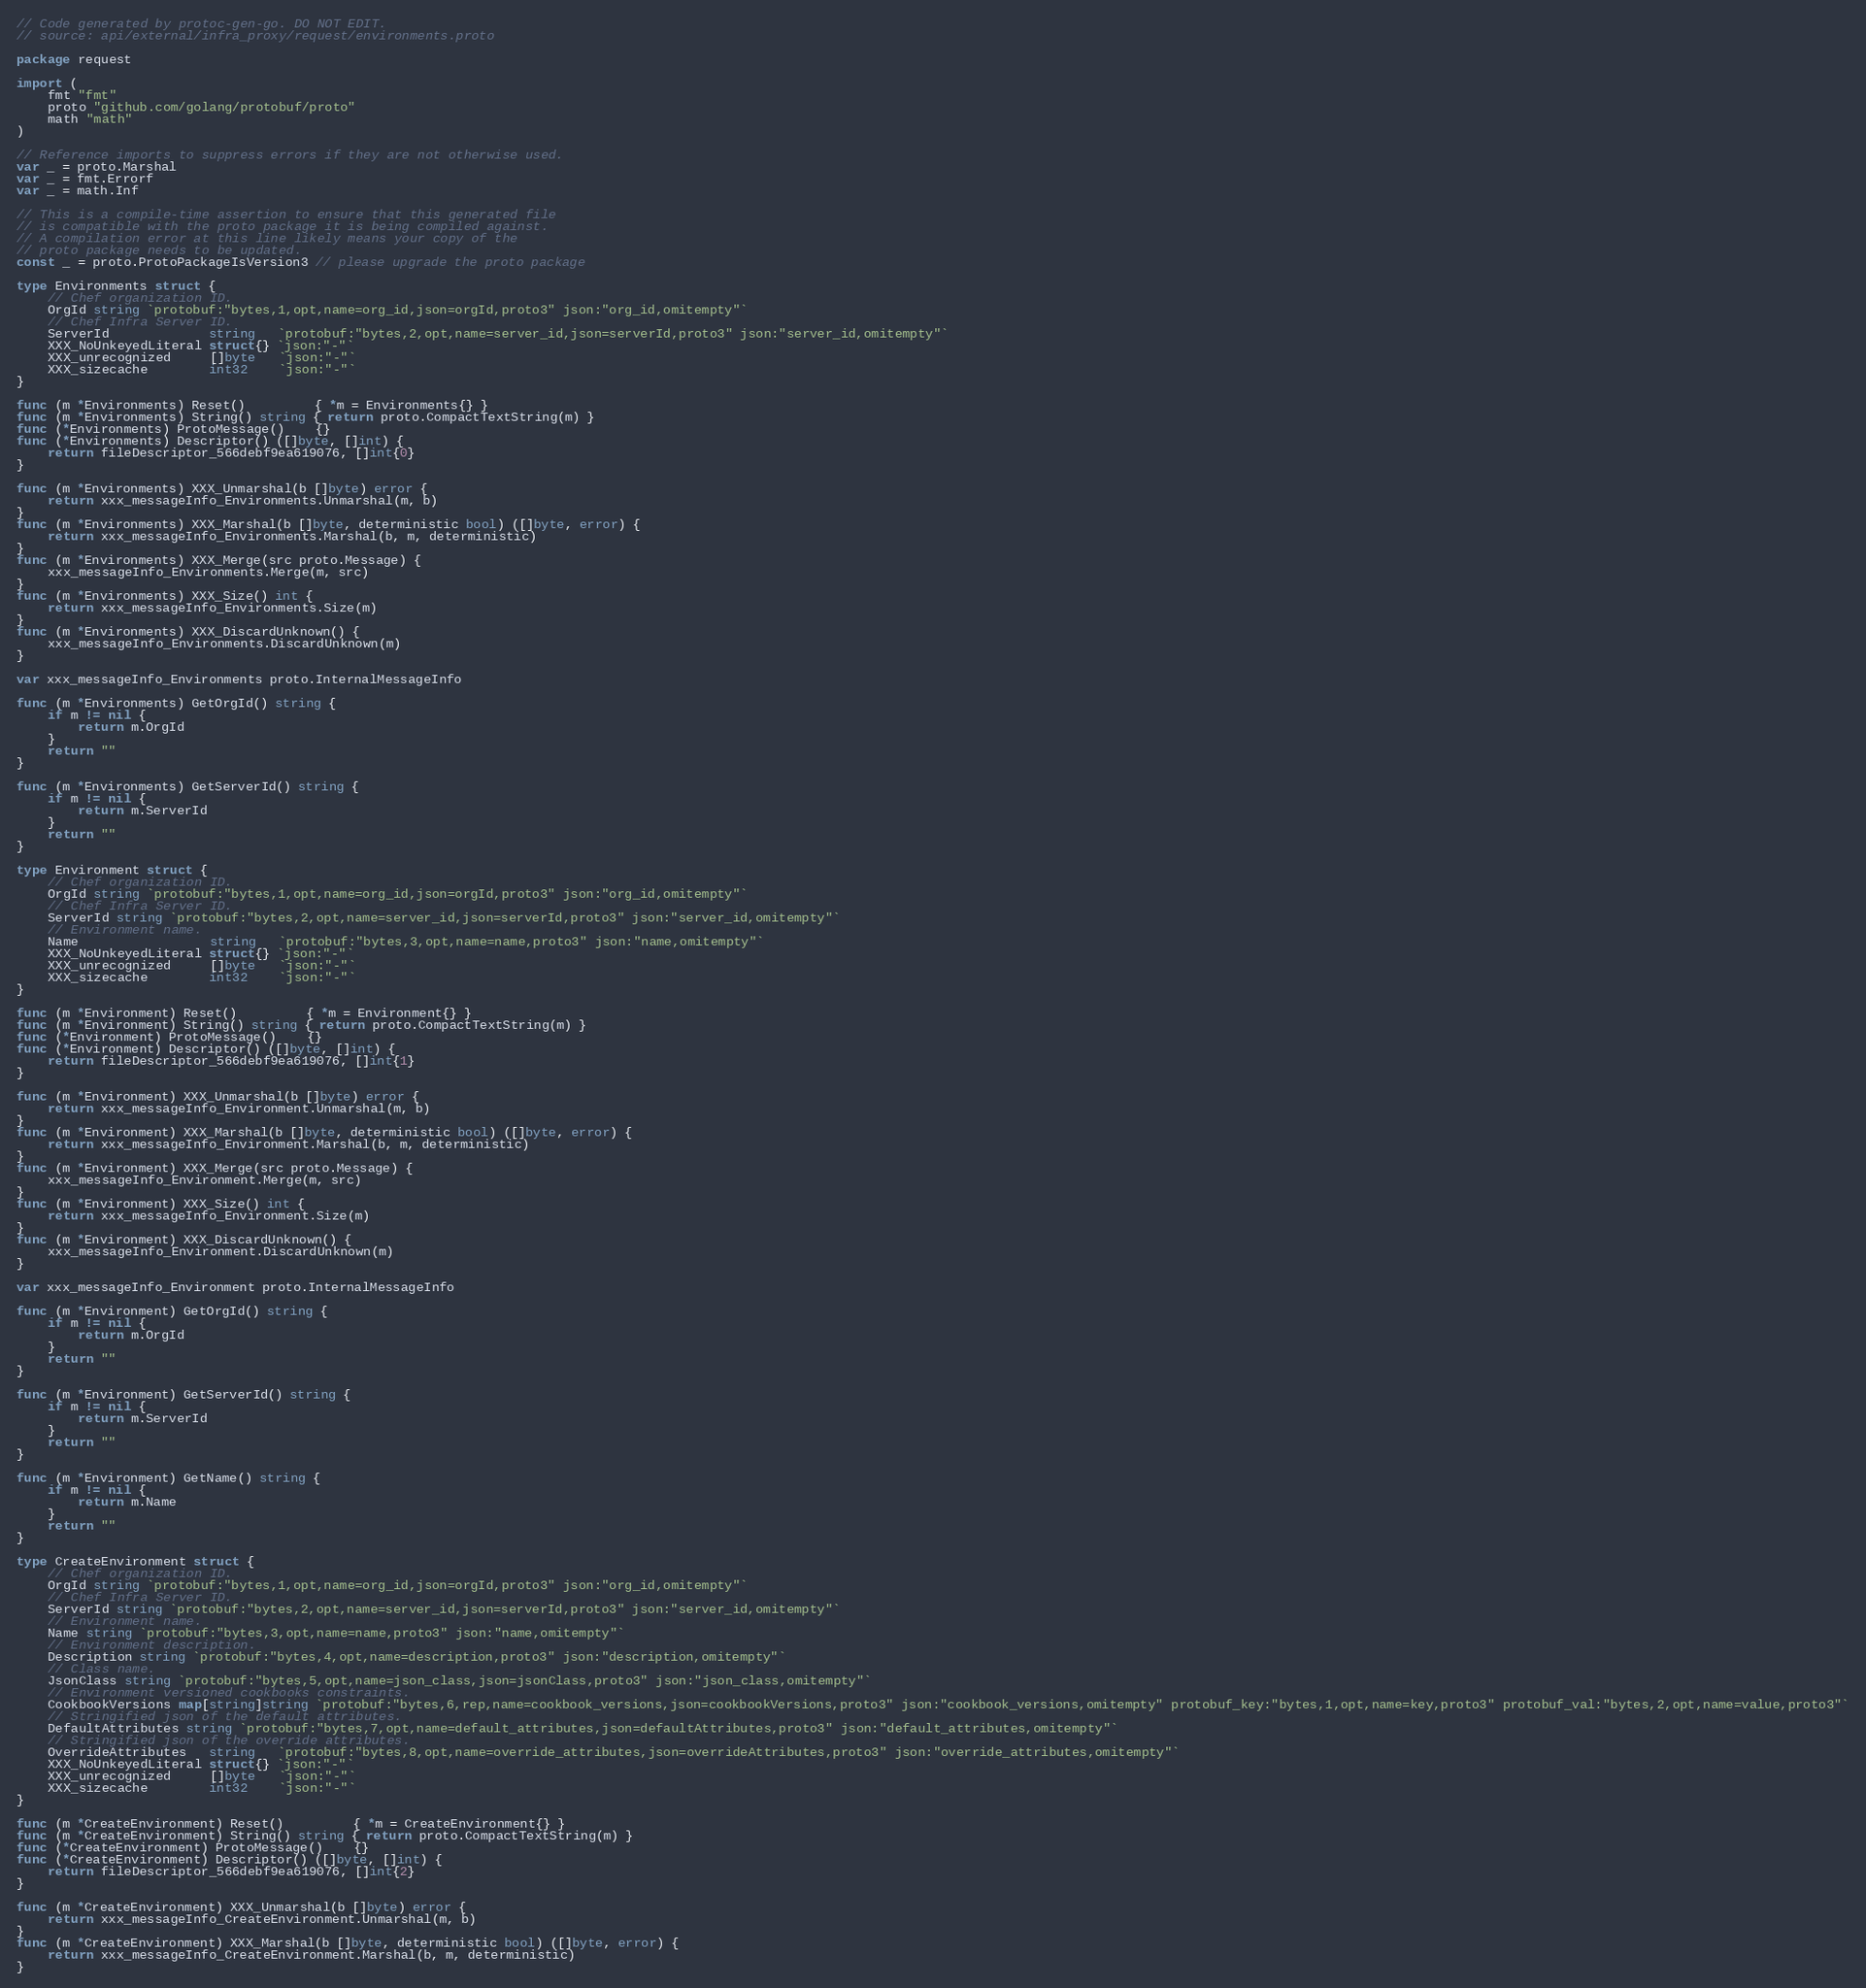<code> <loc_0><loc_0><loc_500><loc_500><_Go_>// Code generated by protoc-gen-go. DO NOT EDIT.
// source: api/external/infra_proxy/request/environments.proto

package request

import (
	fmt "fmt"
	proto "github.com/golang/protobuf/proto"
	math "math"
)

// Reference imports to suppress errors if they are not otherwise used.
var _ = proto.Marshal
var _ = fmt.Errorf
var _ = math.Inf

// This is a compile-time assertion to ensure that this generated file
// is compatible with the proto package it is being compiled against.
// A compilation error at this line likely means your copy of the
// proto package needs to be updated.
const _ = proto.ProtoPackageIsVersion3 // please upgrade the proto package

type Environments struct {
	// Chef organization ID.
	OrgId string `protobuf:"bytes,1,opt,name=org_id,json=orgId,proto3" json:"org_id,omitempty"`
	// Chef Infra Server ID.
	ServerId             string   `protobuf:"bytes,2,opt,name=server_id,json=serverId,proto3" json:"server_id,omitempty"`
	XXX_NoUnkeyedLiteral struct{} `json:"-"`
	XXX_unrecognized     []byte   `json:"-"`
	XXX_sizecache        int32    `json:"-"`
}

func (m *Environments) Reset()         { *m = Environments{} }
func (m *Environments) String() string { return proto.CompactTextString(m) }
func (*Environments) ProtoMessage()    {}
func (*Environments) Descriptor() ([]byte, []int) {
	return fileDescriptor_566debf9ea619076, []int{0}
}

func (m *Environments) XXX_Unmarshal(b []byte) error {
	return xxx_messageInfo_Environments.Unmarshal(m, b)
}
func (m *Environments) XXX_Marshal(b []byte, deterministic bool) ([]byte, error) {
	return xxx_messageInfo_Environments.Marshal(b, m, deterministic)
}
func (m *Environments) XXX_Merge(src proto.Message) {
	xxx_messageInfo_Environments.Merge(m, src)
}
func (m *Environments) XXX_Size() int {
	return xxx_messageInfo_Environments.Size(m)
}
func (m *Environments) XXX_DiscardUnknown() {
	xxx_messageInfo_Environments.DiscardUnknown(m)
}

var xxx_messageInfo_Environments proto.InternalMessageInfo

func (m *Environments) GetOrgId() string {
	if m != nil {
		return m.OrgId
	}
	return ""
}

func (m *Environments) GetServerId() string {
	if m != nil {
		return m.ServerId
	}
	return ""
}

type Environment struct {
	// Chef organization ID.
	OrgId string `protobuf:"bytes,1,opt,name=org_id,json=orgId,proto3" json:"org_id,omitempty"`
	// Chef Infra Server ID.
	ServerId string `protobuf:"bytes,2,opt,name=server_id,json=serverId,proto3" json:"server_id,omitempty"`
	// Environment name.
	Name                 string   `protobuf:"bytes,3,opt,name=name,proto3" json:"name,omitempty"`
	XXX_NoUnkeyedLiteral struct{} `json:"-"`
	XXX_unrecognized     []byte   `json:"-"`
	XXX_sizecache        int32    `json:"-"`
}

func (m *Environment) Reset()         { *m = Environment{} }
func (m *Environment) String() string { return proto.CompactTextString(m) }
func (*Environment) ProtoMessage()    {}
func (*Environment) Descriptor() ([]byte, []int) {
	return fileDescriptor_566debf9ea619076, []int{1}
}

func (m *Environment) XXX_Unmarshal(b []byte) error {
	return xxx_messageInfo_Environment.Unmarshal(m, b)
}
func (m *Environment) XXX_Marshal(b []byte, deterministic bool) ([]byte, error) {
	return xxx_messageInfo_Environment.Marshal(b, m, deterministic)
}
func (m *Environment) XXX_Merge(src proto.Message) {
	xxx_messageInfo_Environment.Merge(m, src)
}
func (m *Environment) XXX_Size() int {
	return xxx_messageInfo_Environment.Size(m)
}
func (m *Environment) XXX_DiscardUnknown() {
	xxx_messageInfo_Environment.DiscardUnknown(m)
}

var xxx_messageInfo_Environment proto.InternalMessageInfo

func (m *Environment) GetOrgId() string {
	if m != nil {
		return m.OrgId
	}
	return ""
}

func (m *Environment) GetServerId() string {
	if m != nil {
		return m.ServerId
	}
	return ""
}

func (m *Environment) GetName() string {
	if m != nil {
		return m.Name
	}
	return ""
}

type CreateEnvironment struct {
	// Chef organization ID.
	OrgId string `protobuf:"bytes,1,opt,name=org_id,json=orgId,proto3" json:"org_id,omitempty"`
	// Chef Infra Server ID.
	ServerId string `protobuf:"bytes,2,opt,name=server_id,json=serverId,proto3" json:"server_id,omitempty"`
	// Environment name.
	Name string `protobuf:"bytes,3,opt,name=name,proto3" json:"name,omitempty"`
	// Environment description.
	Description string `protobuf:"bytes,4,opt,name=description,proto3" json:"description,omitempty"`
	// Class name.
	JsonClass string `protobuf:"bytes,5,opt,name=json_class,json=jsonClass,proto3" json:"json_class,omitempty"`
	// Environment versioned cookbooks constraints.
	CookbookVersions map[string]string `protobuf:"bytes,6,rep,name=cookbook_versions,json=cookbookVersions,proto3" json:"cookbook_versions,omitempty" protobuf_key:"bytes,1,opt,name=key,proto3" protobuf_val:"bytes,2,opt,name=value,proto3"`
	// Stringified json of the default attributes.
	DefaultAttributes string `protobuf:"bytes,7,opt,name=default_attributes,json=defaultAttributes,proto3" json:"default_attributes,omitempty"`
	// Stringified json of the override attributes.
	OverrideAttributes   string   `protobuf:"bytes,8,opt,name=override_attributes,json=overrideAttributes,proto3" json:"override_attributes,omitempty"`
	XXX_NoUnkeyedLiteral struct{} `json:"-"`
	XXX_unrecognized     []byte   `json:"-"`
	XXX_sizecache        int32    `json:"-"`
}

func (m *CreateEnvironment) Reset()         { *m = CreateEnvironment{} }
func (m *CreateEnvironment) String() string { return proto.CompactTextString(m) }
func (*CreateEnvironment) ProtoMessage()    {}
func (*CreateEnvironment) Descriptor() ([]byte, []int) {
	return fileDescriptor_566debf9ea619076, []int{2}
}

func (m *CreateEnvironment) XXX_Unmarshal(b []byte) error {
	return xxx_messageInfo_CreateEnvironment.Unmarshal(m, b)
}
func (m *CreateEnvironment) XXX_Marshal(b []byte, deterministic bool) ([]byte, error) {
	return xxx_messageInfo_CreateEnvironment.Marshal(b, m, deterministic)
}</code> 